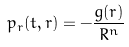<formula> <loc_0><loc_0><loc_500><loc_500>p _ { r } ( t , r ) = - \frac { g ( r ) } { R ^ { n } }</formula> 